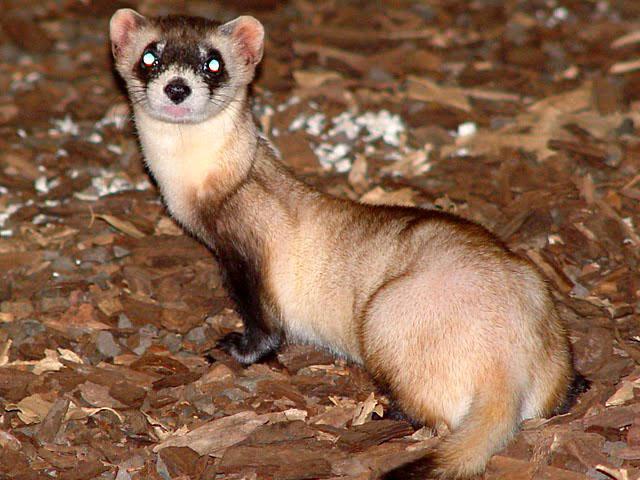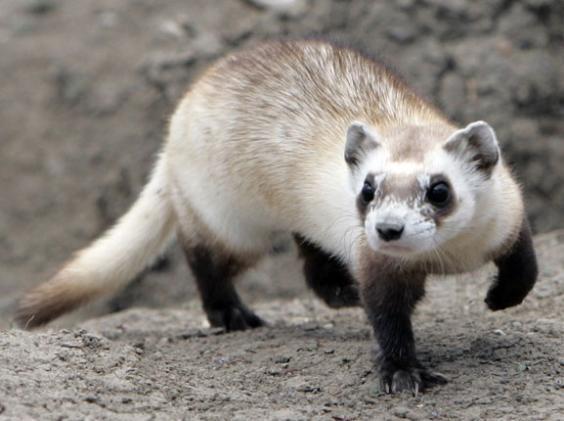The first image is the image on the left, the second image is the image on the right. Examine the images to the left and right. Is the description "One of the animals stands at the entrance to a hole." accurate? Answer yes or no. No. 